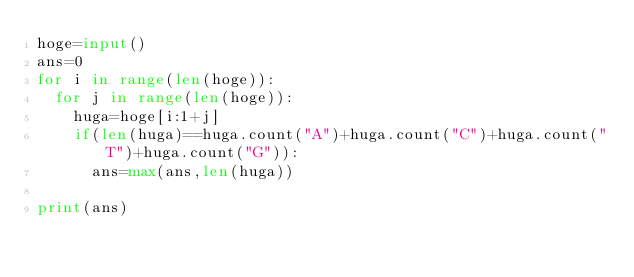Convert code to text. <code><loc_0><loc_0><loc_500><loc_500><_Python_>hoge=input()
ans=0
for i in range(len(hoge)):
  for j in range(len(hoge)):
    huga=hoge[i:1+j]
    if(len(huga)==huga.count("A")+huga.count("C")+huga.count("T")+huga.count("G")):
      ans=max(ans,len(huga))

print(ans)</code> 